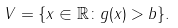Convert formula to latex. <formula><loc_0><loc_0><loc_500><loc_500>V = \{ x \in \mathbb { R } \colon g ( x ) > b \} .</formula> 